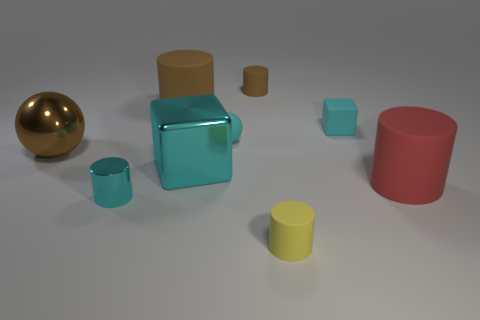What is the material of the large cylinder that is in front of the small ball?
Keep it short and to the point. Rubber. What number of other objects are the same size as the red thing?
Provide a succinct answer. 3. Is the size of the brown metallic sphere the same as the cube in front of the brown ball?
Offer a terse response. Yes. There is a cyan shiny object that is behind the large red cylinder that is on the right side of the big rubber object that is on the left side of the red matte thing; what is its shape?
Provide a short and direct response. Cube. Is the number of small yellow matte cylinders less than the number of large matte cylinders?
Your answer should be compact. Yes. There is a large red rubber thing; are there any small cylinders in front of it?
Offer a very short reply. Yes. There is a cyan object that is behind the large metallic ball and left of the tiny yellow rubber thing; what shape is it?
Provide a succinct answer. Sphere. Is there another thing that has the same shape as the small yellow matte thing?
Ensure brevity in your answer.  Yes. There is a rubber object that is in front of the red matte object; is it the same size as the metallic thing that is on the right side of the small cyan metal thing?
Offer a terse response. No. Are there more large cyan metal blocks than small things?
Provide a succinct answer. No. 